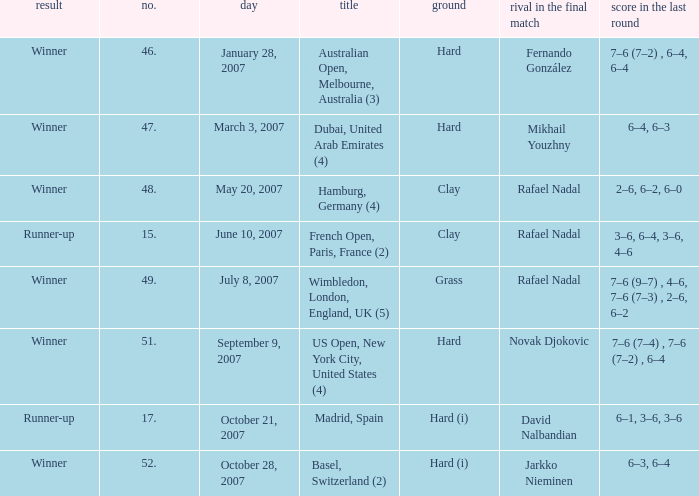On the date October 21, 2007, what is the No.? 17.0. 